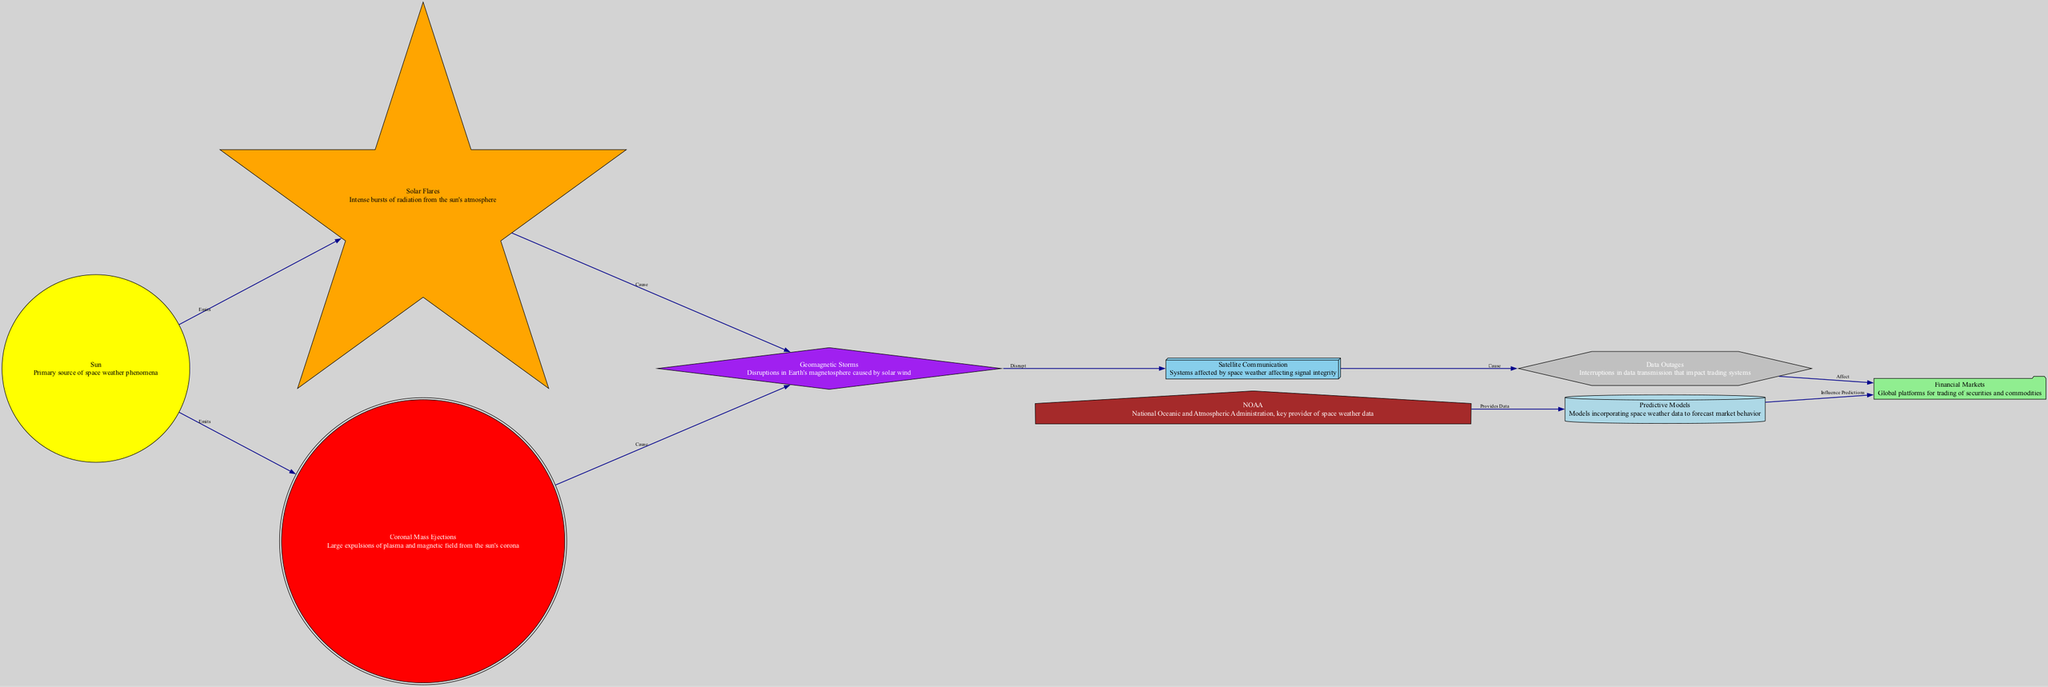What is the primary source of space weather phenomena? In the diagram, the node labeled "Sun" is indicated as the primary source of space weather phenomena, which is shown prominently at the start of the flow.
Answer: Sun How many nodes are connected to the "Geomagnetic Storms" node? By inspecting the diagram, "Geomagnetic Storms" has two outgoing connections: one to "Satellite Communication" and another to "Coronal Mass Ejections", for a total of two connections.
Answer: 2 What do Solar Flares cause? The diagram shows an edge from "Solar Flares" to "Geomagnetic Storms" labeled as "Cause", indicating that Solar Flares are responsible for causing Geomagnetic Storms.
Answer: Geomagnetic Storms Which organization provides data for predictive models? The diagram states that "NOAA" provides data for "Predictive Models", indicating its role in the flow of information.
Answer: NOAA How do Data Outages affect Financial Markets? The edge in the diagram labeled "Affect" from "Data Outages" to "Financial Markets" shows that Data Outages disrupt or impair the functionality within Financial Markets.
Answer: Affect How many types of solar activity are represented in the diagram? The nodes "Solar Flares" and "Coronal Mass Ejections" both represent types of solar activity, and there are therefore two distinct types indicated in the diagram.
Answer: 2 What shape represents the NOAA node? In the diagram, the "NOAA" node is represented with a house shape, which is specified in the visual outlines of the graph.
Answer: House What is the relationship between Geomagnetic Storms and Satellite Communication? The diagram shows that Geomagnetic Storms "Disrupt" Satellite Communication, meaning there is a negative impact on the integrity of its systems due to these storms.
Answer: Disrupt What affects data transmission in the context of this diagram? The diagram indicates that "Satellite Communication" causes "Data Outages", thus data transmission is affected due to issues arising in communication systems.
Answer: Satellite Communication 